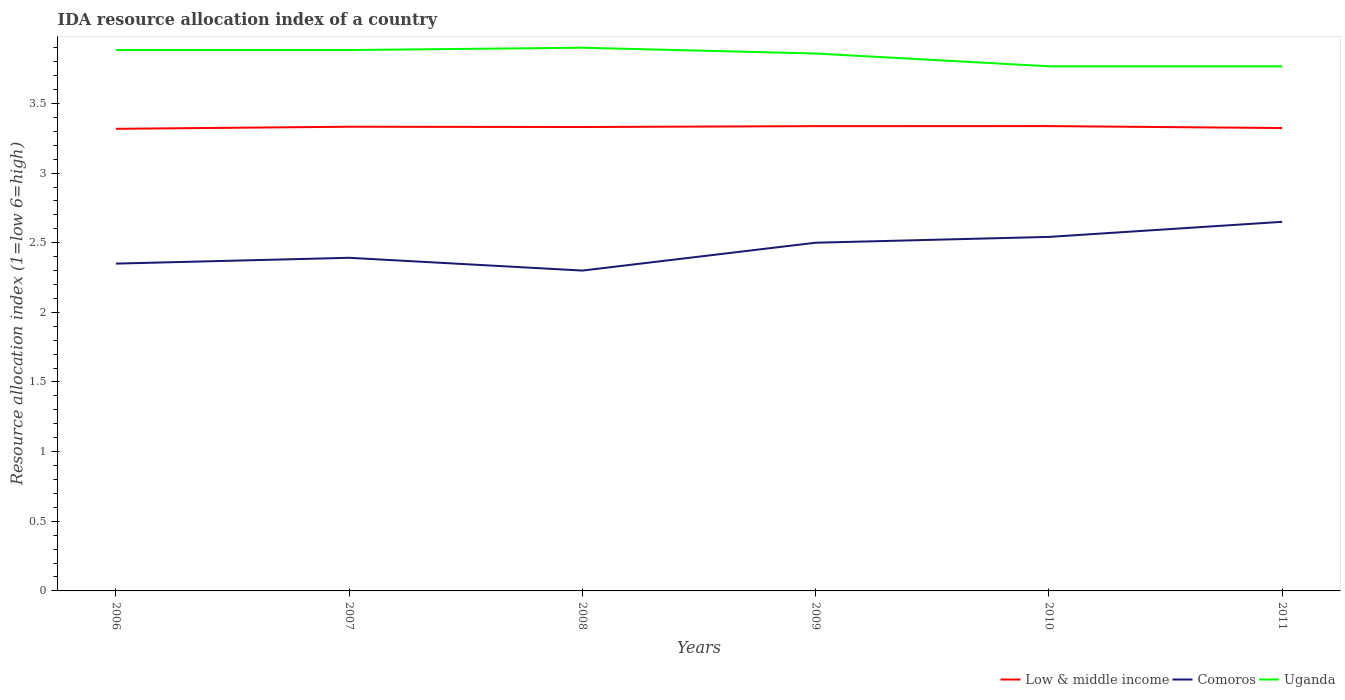Does the line corresponding to Uganda intersect with the line corresponding to Comoros?
Provide a short and direct response. No. Is the number of lines equal to the number of legend labels?
Your answer should be very brief. Yes. Across all years, what is the maximum IDA resource allocation index in Low & middle income?
Offer a very short reply. 3.32. In which year was the IDA resource allocation index in Uganda maximum?
Keep it short and to the point. 2010. What is the total IDA resource allocation index in Uganda in the graph?
Provide a succinct answer. 0.12. What is the difference between the highest and the second highest IDA resource allocation index in Uganda?
Your answer should be compact. 0.13. Is the IDA resource allocation index in Comoros strictly greater than the IDA resource allocation index in Uganda over the years?
Make the answer very short. Yes. How many lines are there?
Offer a terse response. 3. What is the difference between two consecutive major ticks on the Y-axis?
Keep it short and to the point. 0.5. Are the values on the major ticks of Y-axis written in scientific E-notation?
Ensure brevity in your answer.  No. Does the graph contain grids?
Provide a short and direct response. No. How are the legend labels stacked?
Your response must be concise. Horizontal. What is the title of the graph?
Your answer should be compact. IDA resource allocation index of a country. What is the label or title of the X-axis?
Your answer should be compact. Years. What is the label or title of the Y-axis?
Give a very brief answer. Resource allocation index (1=low 6=high). What is the Resource allocation index (1=low 6=high) of Low & middle income in 2006?
Offer a very short reply. 3.32. What is the Resource allocation index (1=low 6=high) of Comoros in 2006?
Your response must be concise. 2.35. What is the Resource allocation index (1=low 6=high) of Uganda in 2006?
Ensure brevity in your answer.  3.88. What is the Resource allocation index (1=low 6=high) in Low & middle income in 2007?
Your answer should be very brief. 3.33. What is the Resource allocation index (1=low 6=high) in Comoros in 2007?
Ensure brevity in your answer.  2.39. What is the Resource allocation index (1=low 6=high) of Uganda in 2007?
Offer a very short reply. 3.88. What is the Resource allocation index (1=low 6=high) of Low & middle income in 2008?
Your answer should be compact. 3.33. What is the Resource allocation index (1=low 6=high) in Uganda in 2008?
Ensure brevity in your answer.  3.9. What is the Resource allocation index (1=low 6=high) in Low & middle income in 2009?
Provide a succinct answer. 3.34. What is the Resource allocation index (1=low 6=high) of Uganda in 2009?
Offer a very short reply. 3.86. What is the Resource allocation index (1=low 6=high) of Low & middle income in 2010?
Give a very brief answer. 3.34. What is the Resource allocation index (1=low 6=high) of Comoros in 2010?
Ensure brevity in your answer.  2.54. What is the Resource allocation index (1=low 6=high) in Uganda in 2010?
Your answer should be very brief. 3.77. What is the Resource allocation index (1=low 6=high) in Low & middle income in 2011?
Offer a terse response. 3.32. What is the Resource allocation index (1=low 6=high) in Comoros in 2011?
Your answer should be compact. 2.65. What is the Resource allocation index (1=low 6=high) of Uganda in 2011?
Your answer should be compact. 3.77. Across all years, what is the maximum Resource allocation index (1=low 6=high) in Low & middle income?
Ensure brevity in your answer.  3.34. Across all years, what is the maximum Resource allocation index (1=low 6=high) in Comoros?
Ensure brevity in your answer.  2.65. Across all years, what is the minimum Resource allocation index (1=low 6=high) of Low & middle income?
Your response must be concise. 3.32. Across all years, what is the minimum Resource allocation index (1=low 6=high) of Comoros?
Ensure brevity in your answer.  2.3. Across all years, what is the minimum Resource allocation index (1=low 6=high) of Uganda?
Give a very brief answer. 3.77. What is the total Resource allocation index (1=low 6=high) of Low & middle income in the graph?
Keep it short and to the point. 19.98. What is the total Resource allocation index (1=low 6=high) in Comoros in the graph?
Offer a very short reply. 14.73. What is the total Resource allocation index (1=low 6=high) in Uganda in the graph?
Provide a succinct answer. 23.06. What is the difference between the Resource allocation index (1=low 6=high) in Low & middle income in 2006 and that in 2007?
Make the answer very short. -0.01. What is the difference between the Resource allocation index (1=low 6=high) in Comoros in 2006 and that in 2007?
Your response must be concise. -0.04. What is the difference between the Resource allocation index (1=low 6=high) in Low & middle income in 2006 and that in 2008?
Offer a very short reply. -0.01. What is the difference between the Resource allocation index (1=low 6=high) in Comoros in 2006 and that in 2008?
Your response must be concise. 0.05. What is the difference between the Resource allocation index (1=low 6=high) in Uganda in 2006 and that in 2008?
Your answer should be compact. -0.02. What is the difference between the Resource allocation index (1=low 6=high) of Low & middle income in 2006 and that in 2009?
Give a very brief answer. -0.02. What is the difference between the Resource allocation index (1=low 6=high) of Uganda in 2006 and that in 2009?
Keep it short and to the point. 0.03. What is the difference between the Resource allocation index (1=low 6=high) of Low & middle income in 2006 and that in 2010?
Give a very brief answer. -0.02. What is the difference between the Resource allocation index (1=low 6=high) of Comoros in 2006 and that in 2010?
Keep it short and to the point. -0.19. What is the difference between the Resource allocation index (1=low 6=high) of Uganda in 2006 and that in 2010?
Your answer should be very brief. 0.12. What is the difference between the Resource allocation index (1=low 6=high) of Low & middle income in 2006 and that in 2011?
Give a very brief answer. -0.01. What is the difference between the Resource allocation index (1=low 6=high) of Comoros in 2006 and that in 2011?
Provide a short and direct response. -0.3. What is the difference between the Resource allocation index (1=low 6=high) of Uganda in 2006 and that in 2011?
Offer a very short reply. 0.12. What is the difference between the Resource allocation index (1=low 6=high) of Low & middle income in 2007 and that in 2008?
Your response must be concise. 0. What is the difference between the Resource allocation index (1=low 6=high) of Comoros in 2007 and that in 2008?
Your answer should be compact. 0.09. What is the difference between the Resource allocation index (1=low 6=high) in Uganda in 2007 and that in 2008?
Your answer should be compact. -0.02. What is the difference between the Resource allocation index (1=low 6=high) of Low & middle income in 2007 and that in 2009?
Make the answer very short. -0. What is the difference between the Resource allocation index (1=low 6=high) of Comoros in 2007 and that in 2009?
Your answer should be very brief. -0.11. What is the difference between the Resource allocation index (1=low 6=high) of Uganda in 2007 and that in 2009?
Provide a succinct answer. 0.03. What is the difference between the Resource allocation index (1=low 6=high) of Low & middle income in 2007 and that in 2010?
Your response must be concise. -0. What is the difference between the Resource allocation index (1=low 6=high) in Uganda in 2007 and that in 2010?
Ensure brevity in your answer.  0.12. What is the difference between the Resource allocation index (1=low 6=high) of Low & middle income in 2007 and that in 2011?
Your response must be concise. 0.01. What is the difference between the Resource allocation index (1=low 6=high) in Comoros in 2007 and that in 2011?
Keep it short and to the point. -0.26. What is the difference between the Resource allocation index (1=low 6=high) in Uganda in 2007 and that in 2011?
Keep it short and to the point. 0.12. What is the difference between the Resource allocation index (1=low 6=high) in Low & middle income in 2008 and that in 2009?
Give a very brief answer. -0.01. What is the difference between the Resource allocation index (1=low 6=high) in Comoros in 2008 and that in 2009?
Keep it short and to the point. -0.2. What is the difference between the Resource allocation index (1=low 6=high) of Uganda in 2008 and that in 2009?
Your response must be concise. 0.04. What is the difference between the Resource allocation index (1=low 6=high) of Low & middle income in 2008 and that in 2010?
Offer a terse response. -0.01. What is the difference between the Resource allocation index (1=low 6=high) of Comoros in 2008 and that in 2010?
Provide a succinct answer. -0.24. What is the difference between the Resource allocation index (1=low 6=high) in Uganda in 2008 and that in 2010?
Provide a short and direct response. 0.13. What is the difference between the Resource allocation index (1=low 6=high) in Low & middle income in 2008 and that in 2011?
Provide a short and direct response. 0.01. What is the difference between the Resource allocation index (1=low 6=high) in Comoros in 2008 and that in 2011?
Your answer should be very brief. -0.35. What is the difference between the Resource allocation index (1=low 6=high) of Uganda in 2008 and that in 2011?
Provide a succinct answer. 0.13. What is the difference between the Resource allocation index (1=low 6=high) of Low & middle income in 2009 and that in 2010?
Your answer should be very brief. -0. What is the difference between the Resource allocation index (1=low 6=high) of Comoros in 2009 and that in 2010?
Your answer should be very brief. -0.04. What is the difference between the Resource allocation index (1=low 6=high) of Uganda in 2009 and that in 2010?
Offer a very short reply. 0.09. What is the difference between the Resource allocation index (1=low 6=high) of Low & middle income in 2009 and that in 2011?
Your answer should be very brief. 0.01. What is the difference between the Resource allocation index (1=low 6=high) in Comoros in 2009 and that in 2011?
Provide a succinct answer. -0.15. What is the difference between the Resource allocation index (1=low 6=high) in Uganda in 2009 and that in 2011?
Provide a succinct answer. 0.09. What is the difference between the Resource allocation index (1=low 6=high) of Low & middle income in 2010 and that in 2011?
Your answer should be compact. 0.01. What is the difference between the Resource allocation index (1=low 6=high) in Comoros in 2010 and that in 2011?
Keep it short and to the point. -0.11. What is the difference between the Resource allocation index (1=low 6=high) in Uganda in 2010 and that in 2011?
Provide a short and direct response. 0. What is the difference between the Resource allocation index (1=low 6=high) in Low & middle income in 2006 and the Resource allocation index (1=low 6=high) in Comoros in 2007?
Your answer should be compact. 0.93. What is the difference between the Resource allocation index (1=low 6=high) in Low & middle income in 2006 and the Resource allocation index (1=low 6=high) in Uganda in 2007?
Your answer should be very brief. -0.57. What is the difference between the Resource allocation index (1=low 6=high) in Comoros in 2006 and the Resource allocation index (1=low 6=high) in Uganda in 2007?
Keep it short and to the point. -1.53. What is the difference between the Resource allocation index (1=low 6=high) of Low & middle income in 2006 and the Resource allocation index (1=low 6=high) of Comoros in 2008?
Offer a very short reply. 1.02. What is the difference between the Resource allocation index (1=low 6=high) of Low & middle income in 2006 and the Resource allocation index (1=low 6=high) of Uganda in 2008?
Keep it short and to the point. -0.58. What is the difference between the Resource allocation index (1=low 6=high) of Comoros in 2006 and the Resource allocation index (1=low 6=high) of Uganda in 2008?
Your answer should be very brief. -1.55. What is the difference between the Resource allocation index (1=low 6=high) in Low & middle income in 2006 and the Resource allocation index (1=low 6=high) in Comoros in 2009?
Ensure brevity in your answer.  0.82. What is the difference between the Resource allocation index (1=low 6=high) of Low & middle income in 2006 and the Resource allocation index (1=low 6=high) of Uganda in 2009?
Your response must be concise. -0.54. What is the difference between the Resource allocation index (1=low 6=high) in Comoros in 2006 and the Resource allocation index (1=low 6=high) in Uganda in 2009?
Provide a succinct answer. -1.51. What is the difference between the Resource allocation index (1=low 6=high) of Low & middle income in 2006 and the Resource allocation index (1=low 6=high) of Comoros in 2010?
Make the answer very short. 0.78. What is the difference between the Resource allocation index (1=low 6=high) of Low & middle income in 2006 and the Resource allocation index (1=low 6=high) of Uganda in 2010?
Your answer should be compact. -0.45. What is the difference between the Resource allocation index (1=low 6=high) in Comoros in 2006 and the Resource allocation index (1=low 6=high) in Uganda in 2010?
Keep it short and to the point. -1.42. What is the difference between the Resource allocation index (1=low 6=high) of Low & middle income in 2006 and the Resource allocation index (1=low 6=high) of Comoros in 2011?
Provide a short and direct response. 0.67. What is the difference between the Resource allocation index (1=low 6=high) of Low & middle income in 2006 and the Resource allocation index (1=low 6=high) of Uganda in 2011?
Your answer should be compact. -0.45. What is the difference between the Resource allocation index (1=low 6=high) of Comoros in 2006 and the Resource allocation index (1=low 6=high) of Uganda in 2011?
Ensure brevity in your answer.  -1.42. What is the difference between the Resource allocation index (1=low 6=high) in Low & middle income in 2007 and the Resource allocation index (1=low 6=high) in Comoros in 2008?
Make the answer very short. 1.03. What is the difference between the Resource allocation index (1=low 6=high) in Low & middle income in 2007 and the Resource allocation index (1=low 6=high) in Uganda in 2008?
Keep it short and to the point. -0.57. What is the difference between the Resource allocation index (1=low 6=high) in Comoros in 2007 and the Resource allocation index (1=low 6=high) in Uganda in 2008?
Offer a terse response. -1.51. What is the difference between the Resource allocation index (1=low 6=high) of Low & middle income in 2007 and the Resource allocation index (1=low 6=high) of Comoros in 2009?
Provide a short and direct response. 0.83. What is the difference between the Resource allocation index (1=low 6=high) in Low & middle income in 2007 and the Resource allocation index (1=low 6=high) in Uganda in 2009?
Make the answer very short. -0.53. What is the difference between the Resource allocation index (1=low 6=high) in Comoros in 2007 and the Resource allocation index (1=low 6=high) in Uganda in 2009?
Your answer should be very brief. -1.47. What is the difference between the Resource allocation index (1=low 6=high) in Low & middle income in 2007 and the Resource allocation index (1=low 6=high) in Comoros in 2010?
Make the answer very short. 0.79. What is the difference between the Resource allocation index (1=low 6=high) in Low & middle income in 2007 and the Resource allocation index (1=low 6=high) in Uganda in 2010?
Give a very brief answer. -0.43. What is the difference between the Resource allocation index (1=low 6=high) of Comoros in 2007 and the Resource allocation index (1=low 6=high) of Uganda in 2010?
Make the answer very short. -1.38. What is the difference between the Resource allocation index (1=low 6=high) of Low & middle income in 2007 and the Resource allocation index (1=low 6=high) of Comoros in 2011?
Provide a short and direct response. 0.68. What is the difference between the Resource allocation index (1=low 6=high) in Low & middle income in 2007 and the Resource allocation index (1=low 6=high) in Uganda in 2011?
Your answer should be very brief. -0.43. What is the difference between the Resource allocation index (1=low 6=high) in Comoros in 2007 and the Resource allocation index (1=low 6=high) in Uganda in 2011?
Give a very brief answer. -1.38. What is the difference between the Resource allocation index (1=low 6=high) of Low & middle income in 2008 and the Resource allocation index (1=low 6=high) of Comoros in 2009?
Ensure brevity in your answer.  0.83. What is the difference between the Resource allocation index (1=low 6=high) of Low & middle income in 2008 and the Resource allocation index (1=low 6=high) of Uganda in 2009?
Keep it short and to the point. -0.53. What is the difference between the Resource allocation index (1=low 6=high) in Comoros in 2008 and the Resource allocation index (1=low 6=high) in Uganda in 2009?
Ensure brevity in your answer.  -1.56. What is the difference between the Resource allocation index (1=low 6=high) of Low & middle income in 2008 and the Resource allocation index (1=low 6=high) of Comoros in 2010?
Your answer should be compact. 0.79. What is the difference between the Resource allocation index (1=low 6=high) of Low & middle income in 2008 and the Resource allocation index (1=low 6=high) of Uganda in 2010?
Keep it short and to the point. -0.44. What is the difference between the Resource allocation index (1=low 6=high) in Comoros in 2008 and the Resource allocation index (1=low 6=high) in Uganda in 2010?
Offer a very short reply. -1.47. What is the difference between the Resource allocation index (1=low 6=high) of Low & middle income in 2008 and the Resource allocation index (1=low 6=high) of Comoros in 2011?
Provide a succinct answer. 0.68. What is the difference between the Resource allocation index (1=low 6=high) in Low & middle income in 2008 and the Resource allocation index (1=low 6=high) in Uganda in 2011?
Make the answer very short. -0.44. What is the difference between the Resource allocation index (1=low 6=high) of Comoros in 2008 and the Resource allocation index (1=low 6=high) of Uganda in 2011?
Make the answer very short. -1.47. What is the difference between the Resource allocation index (1=low 6=high) in Low & middle income in 2009 and the Resource allocation index (1=low 6=high) in Comoros in 2010?
Offer a very short reply. 0.8. What is the difference between the Resource allocation index (1=low 6=high) of Low & middle income in 2009 and the Resource allocation index (1=low 6=high) of Uganda in 2010?
Ensure brevity in your answer.  -0.43. What is the difference between the Resource allocation index (1=low 6=high) of Comoros in 2009 and the Resource allocation index (1=low 6=high) of Uganda in 2010?
Offer a terse response. -1.27. What is the difference between the Resource allocation index (1=low 6=high) in Low & middle income in 2009 and the Resource allocation index (1=low 6=high) in Comoros in 2011?
Your response must be concise. 0.69. What is the difference between the Resource allocation index (1=low 6=high) of Low & middle income in 2009 and the Resource allocation index (1=low 6=high) of Uganda in 2011?
Offer a terse response. -0.43. What is the difference between the Resource allocation index (1=low 6=high) in Comoros in 2009 and the Resource allocation index (1=low 6=high) in Uganda in 2011?
Offer a terse response. -1.27. What is the difference between the Resource allocation index (1=low 6=high) of Low & middle income in 2010 and the Resource allocation index (1=low 6=high) of Comoros in 2011?
Your answer should be very brief. 0.69. What is the difference between the Resource allocation index (1=low 6=high) in Low & middle income in 2010 and the Resource allocation index (1=low 6=high) in Uganda in 2011?
Offer a terse response. -0.43. What is the difference between the Resource allocation index (1=low 6=high) of Comoros in 2010 and the Resource allocation index (1=low 6=high) of Uganda in 2011?
Your response must be concise. -1.23. What is the average Resource allocation index (1=low 6=high) in Low & middle income per year?
Make the answer very short. 3.33. What is the average Resource allocation index (1=low 6=high) of Comoros per year?
Your response must be concise. 2.46. What is the average Resource allocation index (1=low 6=high) in Uganda per year?
Your response must be concise. 3.84. In the year 2006, what is the difference between the Resource allocation index (1=low 6=high) of Low & middle income and Resource allocation index (1=low 6=high) of Comoros?
Your response must be concise. 0.97. In the year 2006, what is the difference between the Resource allocation index (1=low 6=high) of Low & middle income and Resource allocation index (1=low 6=high) of Uganda?
Provide a succinct answer. -0.57. In the year 2006, what is the difference between the Resource allocation index (1=low 6=high) of Comoros and Resource allocation index (1=low 6=high) of Uganda?
Your answer should be compact. -1.53. In the year 2007, what is the difference between the Resource allocation index (1=low 6=high) of Low & middle income and Resource allocation index (1=low 6=high) of Comoros?
Keep it short and to the point. 0.94. In the year 2007, what is the difference between the Resource allocation index (1=low 6=high) of Low & middle income and Resource allocation index (1=low 6=high) of Uganda?
Make the answer very short. -0.55. In the year 2007, what is the difference between the Resource allocation index (1=low 6=high) in Comoros and Resource allocation index (1=low 6=high) in Uganda?
Keep it short and to the point. -1.49. In the year 2008, what is the difference between the Resource allocation index (1=low 6=high) in Low & middle income and Resource allocation index (1=low 6=high) in Comoros?
Ensure brevity in your answer.  1.03. In the year 2008, what is the difference between the Resource allocation index (1=low 6=high) of Low & middle income and Resource allocation index (1=low 6=high) of Uganda?
Keep it short and to the point. -0.57. In the year 2009, what is the difference between the Resource allocation index (1=low 6=high) of Low & middle income and Resource allocation index (1=low 6=high) of Comoros?
Give a very brief answer. 0.84. In the year 2009, what is the difference between the Resource allocation index (1=low 6=high) in Low & middle income and Resource allocation index (1=low 6=high) in Uganda?
Provide a short and direct response. -0.52. In the year 2009, what is the difference between the Resource allocation index (1=low 6=high) of Comoros and Resource allocation index (1=low 6=high) of Uganda?
Ensure brevity in your answer.  -1.36. In the year 2010, what is the difference between the Resource allocation index (1=low 6=high) of Low & middle income and Resource allocation index (1=low 6=high) of Comoros?
Offer a terse response. 0.8. In the year 2010, what is the difference between the Resource allocation index (1=low 6=high) in Low & middle income and Resource allocation index (1=low 6=high) in Uganda?
Provide a succinct answer. -0.43. In the year 2010, what is the difference between the Resource allocation index (1=low 6=high) in Comoros and Resource allocation index (1=low 6=high) in Uganda?
Give a very brief answer. -1.23. In the year 2011, what is the difference between the Resource allocation index (1=low 6=high) in Low & middle income and Resource allocation index (1=low 6=high) in Comoros?
Give a very brief answer. 0.67. In the year 2011, what is the difference between the Resource allocation index (1=low 6=high) in Low & middle income and Resource allocation index (1=low 6=high) in Uganda?
Your answer should be compact. -0.44. In the year 2011, what is the difference between the Resource allocation index (1=low 6=high) in Comoros and Resource allocation index (1=low 6=high) in Uganda?
Ensure brevity in your answer.  -1.12. What is the ratio of the Resource allocation index (1=low 6=high) of Low & middle income in 2006 to that in 2007?
Your response must be concise. 1. What is the ratio of the Resource allocation index (1=low 6=high) of Comoros in 2006 to that in 2007?
Make the answer very short. 0.98. What is the ratio of the Resource allocation index (1=low 6=high) of Comoros in 2006 to that in 2008?
Offer a terse response. 1.02. What is the ratio of the Resource allocation index (1=low 6=high) of Uganda in 2006 to that in 2008?
Give a very brief answer. 1. What is the ratio of the Resource allocation index (1=low 6=high) in Low & middle income in 2006 to that in 2009?
Keep it short and to the point. 0.99. What is the ratio of the Resource allocation index (1=low 6=high) of Comoros in 2006 to that in 2009?
Give a very brief answer. 0.94. What is the ratio of the Resource allocation index (1=low 6=high) in Uganda in 2006 to that in 2009?
Offer a terse response. 1.01. What is the ratio of the Resource allocation index (1=low 6=high) of Low & middle income in 2006 to that in 2010?
Ensure brevity in your answer.  0.99. What is the ratio of the Resource allocation index (1=low 6=high) in Comoros in 2006 to that in 2010?
Your response must be concise. 0.92. What is the ratio of the Resource allocation index (1=low 6=high) of Uganda in 2006 to that in 2010?
Provide a short and direct response. 1.03. What is the ratio of the Resource allocation index (1=low 6=high) of Low & middle income in 2006 to that in 2011?
Offer a terse response. 1. What is the ratio of the Resource allocation index (1=low 6=high) of Comoros in 2006 to that in 2011?
Provide a succinct answer. 0.89. What is the ratio of the Resource allocation index (1=low 6=high) in Uganda in 2006 to that in 2011?
Make the answer very short. 1.03. What is the ratio of the Resource allocation index (1=low 6=high) of Low & middle income in 2007 to that in 2008?
Ensure brevity in your answer.  1. What is the ratio of the Resource allocation index (1=low 6=high) of Comoros in 2007 to that in 2008?
Offer a terse response. 1.04. What is the ratio of the Resource allocation index (1=low 6=high) of Low & middle income in 2007 to that in 2009?
Your answer should be very brief. 1. What is the ratio of the Resource allocation index (1=low 6=high) in Comoros in 2007 to that in 2009?
Provide a short and direct response. 0.96. What is the ratio of the Resource allocation index (1=low 6=high) in Low & middle income in 2007 to that in 2010?
Provide a succinct answer. 1. What is the ratio of the Resource allocation index (1=low 6=high) in Comoros in 2007 to that in 2010?
Provide a succinct answer. 0.94. What is the ratio of the Resource allocation index (1=low 6=high) in Uganda in 2007 to that in 2010?
Make the answer very short. 1.03. What is the ratio of the Resource allocation index (1=low 6=high) of Comoros in 2007 to that in 2011?
Give a very brief answer. 0.9. What is the ratio of the Resource allocation index (1=low 6=high) of Uganda in 2007 to that in 2011?
Offer a terse response. 1.03. What is the ratio of the Resource allocation index (1=low 6=high) of Low & middle income in 2008 to that in 2009?
Your answer should be very brief. 1. What is the ratio of the Resource allocation index (1=low 6=high) of Uganda in 2008 to that in 2009?
Your answer should be compact. 1.01. What is the ratio of the Resource allocation index (1=low 6=high) of Comoros in 2008 to that in 2010?
Your response must be concise. 0.9. What is the ratio of the Resource allocation index (1=low 6=high) in Uganda in 2008 to that in 2010?
Provide a short and direct response. 1.04. What is the ratio of the Resource allocation index (1=low 6=high) in Comoros in 2008 to that in 2011?
Provide a short and direct response. 0.87. What is the ratio of the Resource allocation index (1=low 6=high) of Uganda in 2008 to that in 2011?
Ensure brevity in your answer.  1.04. What is the ratio of the Resource allocation index (1=low 6=high) in Low & middle income in 2009 to that in 2010?
Give a very brief answer. 1. What is the ratio of the Resource allocation index (1=low 6=high) of Comoros in 2009 to that in 2010?
Keep it short and to the point. 0.98. What is the ratio of the Resource allocation index (1=low 6=high) of Uganda in 2009 to that in 2010?
Give a very brief answer. 1.02. What is the ratio of the Resource allocation index (1=low 6=high) of Low & middle income in 2009 to that in 2011?
Ensure brevity in your answer.  1. What is the ratio of the Resource allocation index (1=low 6=high) in Comoros in 2009 to that in 2011?
Offer a very short reply. 0.94. What is the ratio of the Resource allocation index (1=low 6=high) in Uganda in 2009 to that in 2011?
Give a very brief answer. 1.02. What is the ratio of the Resource allocation index (1=low 6=high) in Low & middle income in 2010 to that in 2011?
Ensure brevity in your answer.  1. What is the ratio of the Resource allocation index (1=low 6=high) of Comoros in 2010 to that in 2011?
Provide a short and direct response. 0.96. What is the ratio of the Resource allocation index (1=low 6=high) in Uganda in 2010 to that in 2011?
Give a very brief answer. 1. What is the difference between the highest and the second highest Resource allocation index (1=low 6=high) of Low & middle income?
Ensure brevity in your answer.  0. What is the difference between the highest and the second highest Resource allocation index (1=low 6=high) of Comoros?
Keep it short and to the point. 0.11. What is the difference between the highest and the second highest Resource allocation index (1=low 6=high) in Uganda?
Give a very brief answer. 0.02. What is the difference between the highest and the lowest Resource allocation index (1=low 6=high) in Low & middle income?
Your answer should be compact. 0.02. What is the difference between the highest and the lowest Resource allocation index (1=low 6=high) in Comoros?
Offer a terse response. 0.35. What is the difference between the highest and the lowest Resource allocation index (1=low 6=high) in Uganda?
Offer a very short reply. 0.13. 